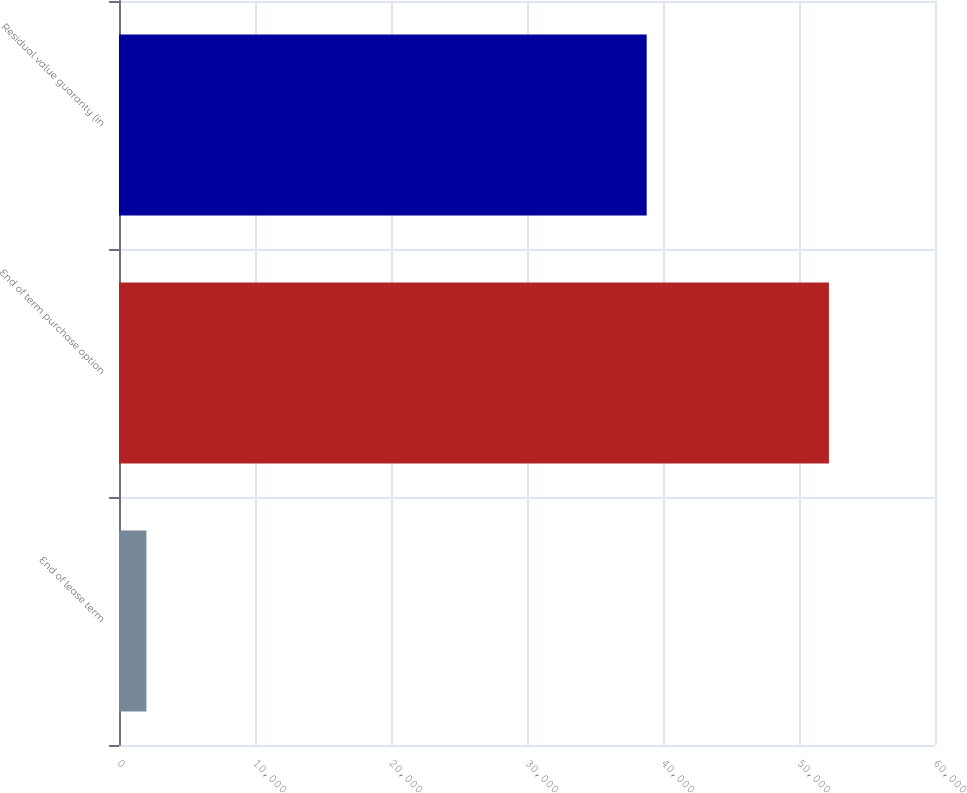Convert chart. <chart><loc_0><loc_0><loc_500><loc_500><bar_chart><fcel>End of lease term<fcel>End of term purchase option<fcel>Residual value guaranty (in<nl><fcel>2015<fcel>52200<fcel>38800<nl></chart> 